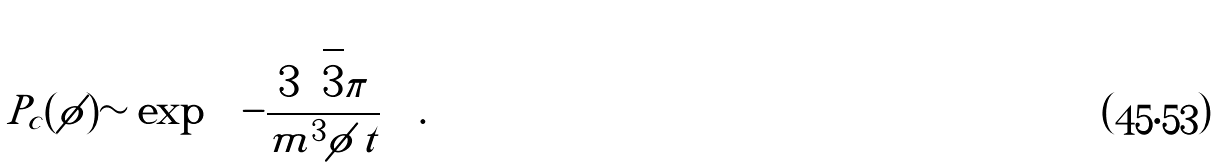Convert formula to latex. <formula><loc_0><loc_0><loc_500><loc_500>P _ { c } ( \phi ) \sim \exp \left ( - \frac { 3 \sqrt { 3 } \pi } { m ^ { 3 } \phi \, t } \right ) .</formula> 